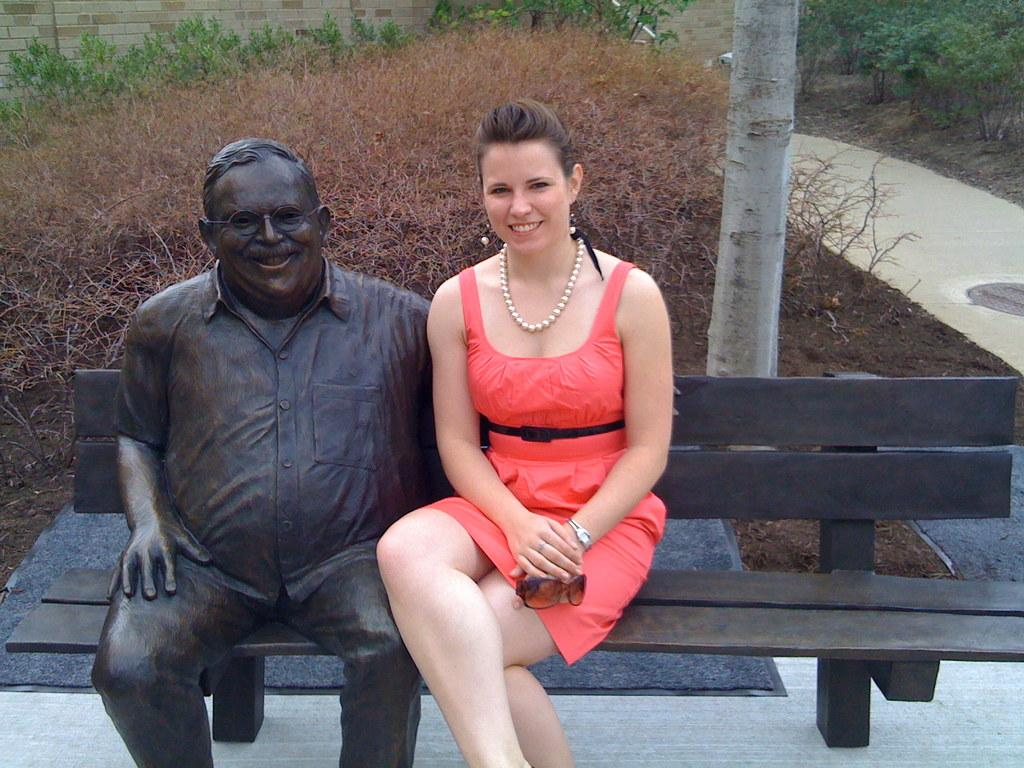Who is present in the image? There is a woman in the image. What is the woman doing in the image? The woman is smiling in the image. What is the woman holding in her hand? The woman is holding goggles in her hand. Where is the woman sitting in the image? The woman is sitting on a bench in the image. What can be seen beside the bench? There is a statue of a man beside the bench. What is visible in the background of the image? There is a wall, trees, a path, and a manhole in the background of the image. Who is the owner of the comb in the image? There is no comb present in the image, so it is not possible to determine the owner. 